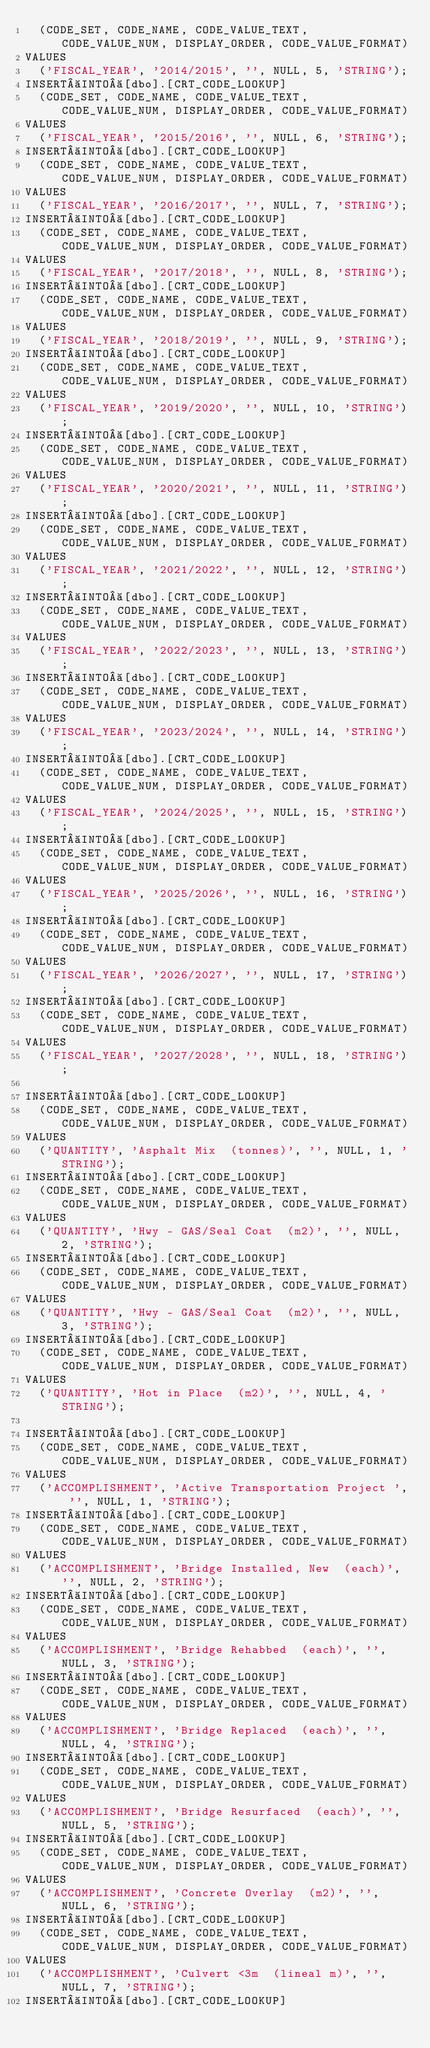Convert code to text. <code><loc_0><loc_0><loc_500><loc_500><_SQL_>	(CODE_SET, CODE_NAME, CODE_VALUE_TEXT, CODE_VALUE_NUM, DISPLAY_ORDER, CODE_VALUE_FORMAT)
VALUES
	('FISCAL_YEAR', '2014/2015', '', NULL, 5, 'STRING');
INSERT INTO [dbo].[CRT_CODE_LOOKUP]
	(CODE_SET, CODE_NAME, CODE_VALUE_TEXT, CODE_VALUE_NUM, DISPLAY_ORDER, CODE_VALUE_FORMAT)
VALUES
	('FISCAL_YEAR', '2015/2016', '', NULL, 6, 'STRING');
INSERT INTO [dbo].[CRT_CODE_LOOKUP]
	(CODE_SET, CODE_NAME, CODE_VALUE_TEXT, CODE_VALUE_NUM, DISPLAY_ORDER, CODE_VALUE_FORMAT)
VALUES
	('FISCAL_YEAR', '2016/2017', '', NULL, 7, 'STRING');
INSERT INTO [dbo].[CRT_CODE_LOOKUP]
	(CODE_SET, CODE_NAME, CODE_VALUE_TEXT, CODE_VALUE_NUM, DISPLAY_ORDER, CODE_VALUE_FORMAT)
VALUES
	('FISCAL_YEAR', '2017/2018', '', NULL, 8, 'STRING');
INSERT INTO [dbo].[CRT_CODE_LOOKUP]
	(CODE_SET, CODE_NAME, CODE_VALUE_TEXT, CODE_VALUE_NUM, DISPLAY_ORDER, CODE_VALUE_FORMAT)
VALUES
	('FISCAL_YEAR', '2018/2019', '', NULL, 9, 'STRING');
INSERT INTO [dbo].[CRT_CODE_LOOKUP]
	(CODE_SET, CODE_NAME, CODE_VALUE_TEXT, CODE_VALUE_NUM, DISPLAY_ORDER, CODE_VALUE_FORMAT)
VALUES
	('FISCAL_YEAR', '2019/2020', '', NULL, 10, 'STRING');
INSERT INTO [dbo].[CRT_CODE_LOOKUP]
	(CODE_SET, CODE_NAME, CODE_VALUE_TEXT, CODE_VALUE_NUM, DISPLAY_ORDER, CODE_VALUE_FORMAT)
VALUES
	('FISCAL_YEAR', '2020/2021', '', NULL, 11, 'STRING');
INSERT INTO [dbo].[CRT_CODE_LOOKUP]
	(CODE_SET, CODE_NAME, CODE_VALUE_TEXT, CODE_VALUE_NUM, DISPLAY_ORDER, CODE_VALUE_FORMAT)
VALUES
	('FISCAL_YEAR', '2021/2022', '', NULL, 12, 'STRING');
INSERT INTO [dbo].[CRT_CODE_LOOKUP]
	(CODE_SET, CODE_NAME, CODE_VALUE_TEXT, CODE_VALUE_NUM, DISPLAY_ORDER, CODE_VALUE_FORMAT)
VALUES
	('FISCAL_YEAR', '2022/2023', '', NULL, 13, 'STRING');
INSERT INTO [dbo].[CRT_CODE_LOOKUP]
	(CODE_SET, CODE_NAME, CODE_VALUE_TEXT, CODE_VALUE_NUM, DISPLAY_ORDER, CODE_VALUE_FORMAT)
VALUES
	('FISCAL_YEAR', '2023/2024', '', NULL, 14, 'STRING');
INSERT INTO [dbo].[CRT_CODE_LOOKUP]
	(CODE_SET, CODE_NAME, CODE_VALUE_TEXT, CODE_VALUE_NUM, DISPLAY_ORDER, CODE_VALUE_FORMAT)
VALUES
	('FISCAL_YEAR', '2024/2025', '', NULL, 15, 'STRING');
INSERT INTO [dbo].[CRT_CODE_LOOKUP]
	(CODE_SET, CODE_NAME, CODE_VALUE_TEXT, CODE_VALUE_NUM, DISPLAY_ORDER, CODE_VALUE_FORMAT)
VALUES
	('FISCAL_YEAR', '2025/2026', '', NULL, 16, 'STRING');
INSERT INTO [dbo].[CRT_CODE_LOOKUP]
	(CODE_SET, CODE_NAME, CODE_VALUE_TEXT, CODE_VALUE_NUM, DISPLAY_ORDER, CODE_VALUE_FORMAT)
VALUES
	('FISCAL_YEAR', '2026/2027', '', NULL, 17, 'STRING');
INSERT INTO [dbo].[CRT_CODE_LOOKUP]
	(CODE_SET, CODE_NAME, CODE_VALUE_TEXT, CODE_VALUE_NUM, DISPLAY_ORDER, CODE_VALUE_FORMAT)
VALUES
	('FISCAL_YEAR', '2027/2028', '', NULL, 18, 'STRING');

INSERT INTO [dbo].[CRT_CODE_LOOKUP]
	(CODE_SET, CODE_NAME, CODE_VALUE_TEXT, CODE_VALUE_NUM, DISPLAY_ORDER, CODE_VALUE_FORMAT)
VALUES
	('QUANTITY', 'Asphalt Mix  (tonnes)', '', NULL, 1, 'STRING');
INSERT INTO [dbo].[CRT_CODE_LOOKUP]
	(CODE_SET, CODE_NAME, CODE_VALUE_TEXT, CODE_VALUE_NUM, DISPLAY_ORDER, CODE_VALUE_FORMAT)
VALUES
	('QUANTITY', 'Hwy - GAS/Seal Coat  (m2)', '', NULL, 2, 'STRING');
INSERT INTO [dbo].[CRT_CODE_LOOKUP]
	(CODE_SET, CODE_NAME, CODE_VALUE_TEXT, CODE_VALUE_NUM, DISPLAY_ORDER, CODE_VALUE_FORMAT)
VALUES
	('QUANTITY', 'Hwy - GAS/Seal Coat  (m2)', '', NULL, 3, 'STRING');
INSERT INTO [dbo].[CRT_CODE_LOOKUP]
	(CODE_SET, CODE_NAME, CODE_VALUE_TEXT, CODE_VALUE_NUM, DISPLAY_ORDER, CODE_VALUE_FORMAT)
VALUES
	('QUANTITY', 'Hot in Place  (m2)', '', NULL, 4, 'STRING');

INSERT INTO [dbo].[CRT_CODE_LOOKUP]
	(CODE_SET, CODE_NAME, CODE_VALUE_TEXT, CODE_VALUE_NUM, DISPLAY_ORDER, CODE_VALUE_FORMAT)
VALUES
	('ACCOMPLISHMENT', 'Active Transportation Project ', '', NULL, 1, 'STRING');
INSERT INTO [dbo].[CRT_CODE_LOOKUP]
	(CODE_SET, CODE_NAME, CODE_VALUE_TEXT, CODE_VALUE_NUM, DISPLAY_ORDER, CODE_VALUE_FORMAT)
VALUES
	('ACCOMPLISHMENT', 'Bridge Installed, New  (each)', '', NULL, 2, 'STRING');
INSERT INTO [dbo].[CRT_CODE_LOOKUP]
	(CODE_SET, CODE_NAME, CODE_VALUE_TEXT, CODE_VALUE_NUM, DISPLAY_ORDER, CODE_VALUE_FORMAT)
VALUES
	('ACCOMPLISHMENT', 'Bridge Rehabbed  (each)', '', NULL, 3, 'STRING');
INSERT INTO [dbo].[CRT_CODE_LOOKUP]
	(CODE_SET, CODE_NAME, CODE_VALUE_TEXT, CODE_VALUE_NUM, DISPLAY_ORDER, CODE_VALUE_FORMAT)
VALUES
	('ACCOMPLISHMENT', 'Bridge Replaced  (each)', '', NULL, 4, 'STRING');
INSERT INTO [dbo].[CRT_CODE_LOOKUP]
	(CODE_SET, CODE_NAME, CODE_VALUE_TEXT, CODE_VALUE_NUM, DISPLAY_ORDER, CODE_VALUE_FORMAT)
VALUES
	('ACCOMPLISHMENT', 'Bridge Resurfaced  (each)', '', NULL, 5, 'STRING');
INSERT INTO [dbo].[CRT_CODE_LOOKUP]
	(CODE_SET, CODE_NAME, CODE_VALUE_TEXT, CODE_VALUE_NUM, DISPLAY_ORDER, CODE_VALUE_FORMAT)
VALUES
	('ACCOMPLISHMENT', 'Concrete Overlay  (m2)', '', NULL, 6, 'STRING');
INSERT INTO [dbo].[CRT_CODE_LOOKUP]
	(CODE_SET, CODE_NAME, CODE_VALUE_TEXT, CODE_VALUE_NUM, DISPLAY_ORDER, CODE_VALUE_FORMAT)
VALUES
	('ACCOMPLISHMENT', 'Culvert <3m  (lineal m)', '', NULL, 7, 'STRING');
INSERT INTO [dbo].[CRT_CODE_LOOKUP]</code> 